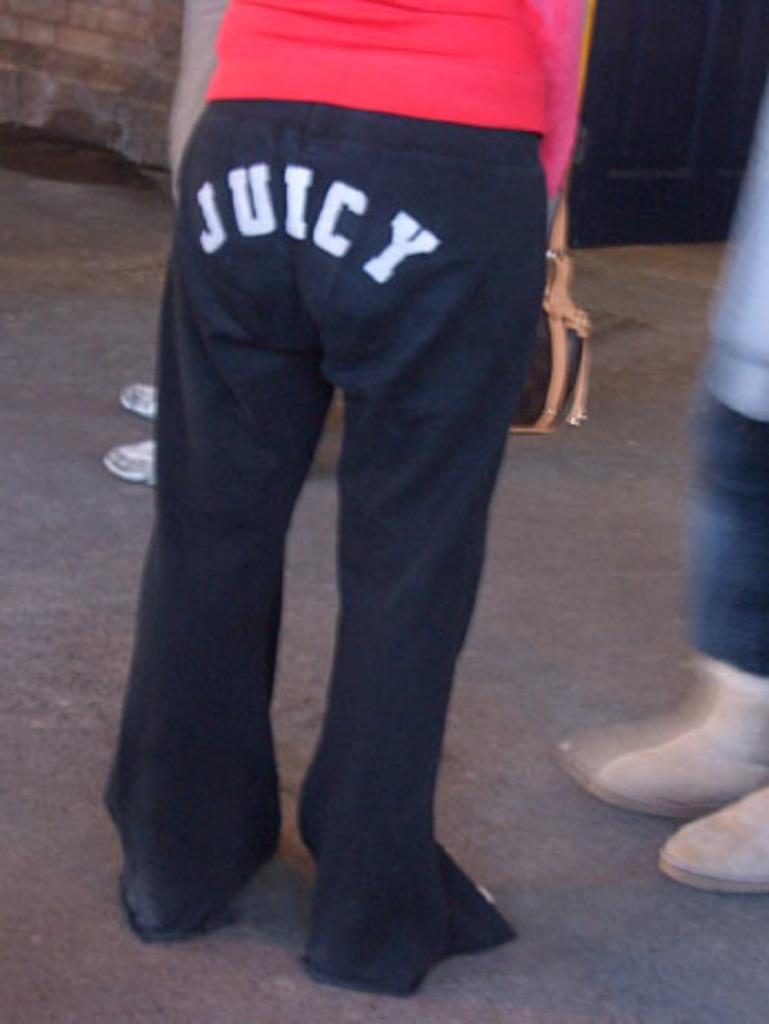Is she saying that her pants are soaked?
Give a very brief answer. Answering does not require reading text in the image. 